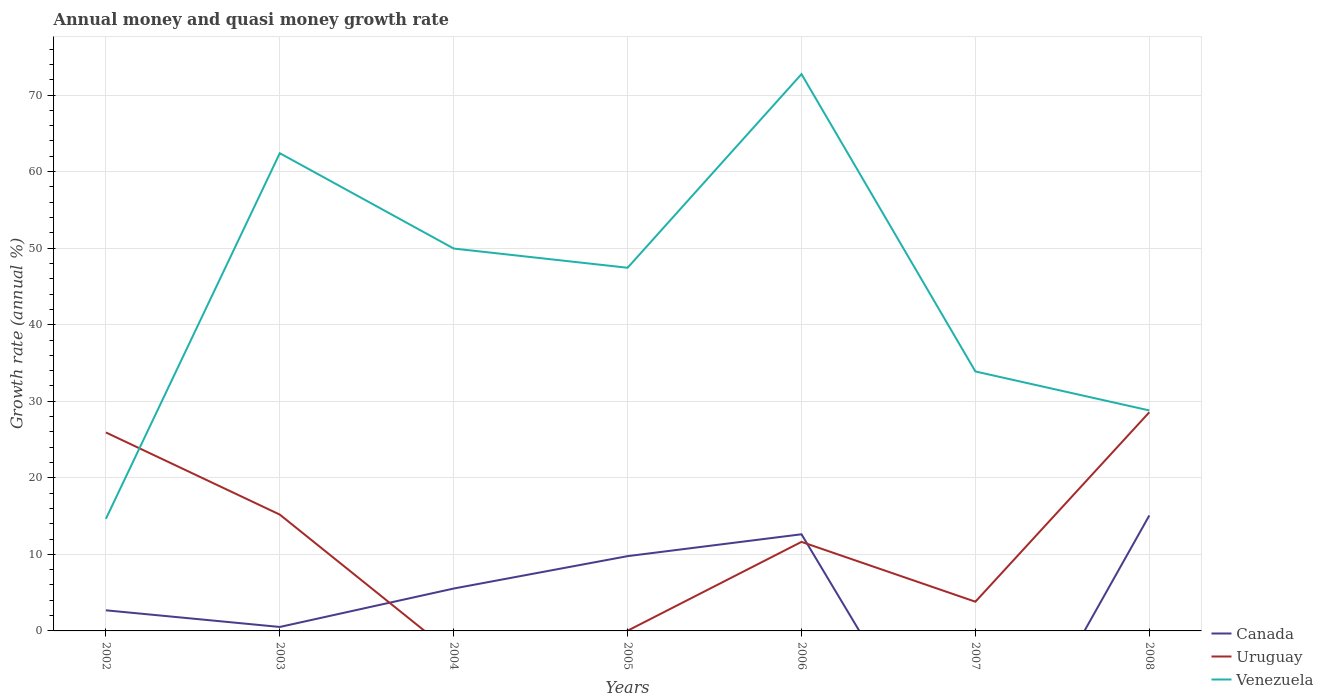Does the line corresponding to Venezuela intersect with the line corresponding to Uruguay?
Offer a very short reply. Yes. Across all years, what is the maximum growth rate in Uruguay?
Give a very brief answer. 0. What is the total growth rate in Uruguay in the graph?
Offer a very short reply. 25.9. What is the difference between the highest and the second highest growth rate in Uruguay?
Provide a succinct answer. 28.57. How many lines are there?
Provide a short and direct response. 3. What is the difference between two consecutive major ticks on the Y-axis?
Ensure brevity in your answer.  10. Does the graph contain any zero values?
Make the answer very short. Yes. Does the graph contain grids?
Ensure brevity in your answer.  Yes. Where does the legend appear in the graph?
Give a very brief answer. Bottom right. How many legend labels are there?
Offer a very short reply. 3. How are the legend labels stacked?
Your answer should be compact. Vertical. What is the title of the graph?
Your response must be concise. Annual money and quasi money growth rate. What is the label or title of the X-axis?
Give a very brief answer. Years. What is the label or title of the Y-axis?
Your answer should be compact. Growth rate (annual %). What is the Growth rate (annual %) in Canada in 2002?
Provide a succinct answer. 2.69. What is the Growth rate (annual %) of Uruguay in 2002?
Keep it short and to the point. 25.93. What is the Growth rate (annual %) in Venezuela in 2002?
Make the answer very short. 14.64. What is the Growth rate (annual %) in Canada in 2003?
Provide a succinct answer. 0.52. What is the Growth rate (annual %) of Uruguay in 2003?
Provide a short and direct response. 15.2. What is the Growth rate (annual %) in Venezuela in 2003?
Provide a succinct answer. 62.41. What is the Growth rate (annual %) in Canada in 2004?
Make the answer very short. 5.54. What is the Growth rate (annual %) in Venezuela in 2004?
Provide a succinct answer. 49.95. What is the Growth rate (annual %) of Canada in 2005?
Offer a terse response. 9.77. What is the Growth rate (annual %) in Uruguay in 2005?
Your answer should be compact. 0.03. What is the Growth rate (annual %) in Venezuela in 2005?
Make the answer very short. 47.44. What is the Growth rate (annual %) in Canada in 2006?
Provide a succinct answer. 12.63. What is the Growth rate (annual %) of Uruguay in 2006?
Keep it short and to the point. 11.63. What is the Growth rate (annual %) in Venezuela in 2006?
Keep it short and to the point. 72.74. What is the Growth rate (annual %) of Uruguay in 2007?
Provide a succinct answer. 3.82. What is the Growth rate (annual %) of Venezuela in 2007?
Your answer should be compact. 33.89. What is the Growth rate (annual %) in Canada in 2008?
Your answer should be very brief. 15.08. What is the Growth rate (annual %) of Uruguay in 2008?
Ensure brevity in your answer.  28.57. What is the Growth rate (annual %) in Venezuela in 2008?
Provide a succinct answer. 28.8. Across all years, what is the maximum Growth rate (annual %) of Canada?
Offer a very short reply. 15.08. Across all years, what is the maximum Growth rate (annual %) in Uruguay?
Your response must be concise. 28.57. Across all years, what is the maximum Growth rate (annual %) of Venezuela?
Your response must be concise. 72.74. Across all years, what is the minimum Growth rate (annual %) in Venezuela?
Provide a short and direct response. 14.64. What is the total Growth rate (annual %) in Canada in the graph?
Ensure brevity in your answer.  46.23. What is the total Growth rate (annual %) in Uruguay in the graph?
Offer a terse response. 85.16. What is the total Growth rate (annual %) in Venezuela in the graph?
Keep it short and to the point. 309.87. What is the difference between the Growth rate (annual %) of Canada in 2002 and that in 2003?
Keep it short and to the point. 2.18. What is the difference between the Growth rate (annual %) of Uruguay in 2002 and that in 2003?
Make the answer very short. 10.73. What is the difference between the Growth rate (annual %) of Venezuela in 2002 and that in 2003?
Ensure brevity in your answer.  -47.77. What is the difference between the Growth rate (annual %) of Canada in 2002 and that in 2004?
Ensure brevity in your answer.  -2.84. What is the difference between the Growth rate (annual %) in Venezuela in 2002 and that in 2004?
Your answer should be very brief. -35.31. What is the difference between the Growth rate (annual %) of Canada in 2002 and that in 2005?
Your response must be concise. -7.08. What is the difference between the Growth rate (annual %) in Uruguay in 2002 and that in 2005?
Keep it short and to the point. 25.9. What is the difference between the Growth rate (annual %) in Venezuela in 2002 and that in 2005?
Give a very brief answer. -32.8. What is the difference between the Growth rate (annual %) in Canada in 2002 and that in 2006?
Your response must be concise. -9.93. What is the difference between the Growth rate (annual %) in Uruguay in 2002 and that in 2006?
Give a very brief answer. 14.3. What is the difference between the Growth rate (annual %) in Venezuela in 2002 and that in 2006?
Your answer should be compact. -58.1. What is the difference between the Growth rate (annual %) of Uruguay in 2002 and that in 2007?
Ensure brevity in your answer.  22.11. What is the difference between the Growth rate (annual %) in Venezuela in 2002 and that in 2007?
Ensure brevity in your answer.  -19.25. What is the difference between the Growth rate (annual %) of Canada in 2002 and that in 2008?
Ensure brevity in your answer.  -12.39. What is the difference between the Growth rate (annual %) in Uruguay in 2002 and that in 2008?
Ensure brevity in your answer.  -2.64. What is the difference between the Growth rate (annual %) of Venezuela in 2002 and that in 2008?
Make the answer very short. -14.16. What is the difference between the Growth rate (annual %) in Canada in 2003 and that in 2004?
Offer a very short reply. -5.02. What is the difference between the Growth rate (annual %) in Venezuela in 2003 and that in 2004?
Your response must be concise. 12.45. What is the difference between the Growth rate (annual %) of Canada in 2003 and that in 2005?
Ensure brevity in your answer.  -9.25. What is the difference between the Growth rate (annual %) in Uruguay in 2003 and that in 2005?
Offer a terse response. 15.17. What is the difference between the Growth rate (annual %) of Venezuela in 2003 and that in 2005?
Ensure brevity in your answer.  14.97. What is the difference between the Growth rate (annual %) of Canada in 2003 and that in 2006?
Your answer should be very brief. -12.11. What is the difference between the Growth rate (annual %) of Uruguay in 2003 and that in 2006?
Offer a terse response. 3.56. What is the difference between the Growth rate (annual %) in Venezuela in 2003 and that in 2006?
Provide a short and direct response. -10.33. What is the difference between the Growth rate (annual %) in Uruguay in 2003 and that in 2007?
Provide a succinct answer. 11.38. What is the difference between the Growth rate (annual %) in Venezuela in 2003 and that in 2007?
Provide a succinct answer. 28.51. What is the difference between the Growth rate (annual %) of Canada in 2003 and that in 2008?
Offer a terse response. -14.57. What is the difference between the Growth rate (annual %) in Uruguay in 2003 and that in 2008?
Provide a succinct answer. -13.37. What is the difference between the Growth rate (annual %) of Venezuela in 2003 and that in 2008?
Keep it short and to the point. 33.6. What is the difference between the Growth rate (annual %) in Canada in 2004 and that in 2005?
Keep it short and to the point. -4.23. What is the difference between the Growth rate (annual %) of Venezuela in 2004 and that in 2005?
Offer a terse response. 2.51. What is the difference between the Growth rate (annual %) of Canada in 2004 and that in 2006?
Offer a terse response. -7.09. What is the difference between the Growth rate (annual %) of Venezuela in 2004 and that in 2006?
Offer a very short reply. -22.78. What is the difference between the Growth rate (annual %) of Venezuela in 2004 and that in 2007?
Your answer should be compact. 16.06. What is the difference between the Growth rate (annual %) in Canada in 2004 and that in 2008?
Provide a succinct answer. -9.55. What is the difference between the Growth rate (annual %) of Venezuela in 2004 and that in 2008?
Offer a very short reply. 21.15. What is the difference between the Growth rate (annual %) of Canada in 2005 and that in 2006?
Provide a succinct answer. -2.86. What is the difference between the Growth rate (annual %) in Uruguay in 2005 and that in 2006?
Give a very brief answer. -11.6. What is the difference between the Growth rate (annual %) in Venezuela in 2005 and that in 2006?
Your response must be concise. -25.3. What is the difference between the Growth rate (annual %) in Uruguay in 2005 and that in 2007?
Offer a terse response. -3.79. What is the difference between the Growth rate (annual %) in Venezuela in 2005 and that in 2007?
Give a very brief answer. 13.55. What is the difference between the Growth rate (annual %) in Canada in 2005 and that in 2008?
Your response must be concise. -5.31. What is the difference between the Growth rate (annual %) of Uruguay in 2005 and that in 2008?
Your answer should be very brief. -28.54. What is the difference between the Growth rate (annual %) of Venezuela in 2005 and that in 2008?
Your answer should be compact. 18.64. What is the difference between the Growth rate (annual %) of Uruguay in 2006 and that in 2007?
Ensure brevity in your answer.  7.82. What is the difference between the Growth rate (annual %) in Venezuela in 2006 and that in 2007?
Make the answer very short. 38.84. What is the difference between the Growth rate (annual %) in Canada in 2006 and that in 2008?
Offer a terse response. -2.46. What is the difference between the Growth rate (annual %) of Uruguay in 2006 and that in 2008?
Provide a succinct answer. -16.93. What is the difference between the Growth rate (annual %) in Venezuela in 2006 and that in 2008?
Offer a terse response. 43.94. What is the difference between the Growth rate (annual %) in Uruguay in 2007 and that in 2008?
Your answer should be compact. -24.75. What is the difference between the Growth rate (annual %) of Venezuela in 2007 and that in 2008?
Give a very brief answer. 5.09. What is the difference between the Growth rate (annual %) of Canada in 2002 and the Growth rate (annual %) of Uruguay in 2003?
Make the answer very short. -12.5. What is the difference between the Growth rate (annual %) of Canada in 2002 and the Growth rate (annual %) of Venezuela in 2003?
Your answer should be compact. -59.71. What is the difference between the Growth rate (annual %) of Uruguay in 2002 and the Growth rate (annual %) of Venezuela in 2003?
Provide a short and direct response. -36.48. What is the difference between the Growth rate (annual %) in Canada in 2002 and the Growth rate (annual %) in Venezuela in 2004?
Make the answer very short. -47.26. What is the difference between the Growth rate (annual %) of Uruguay in 2002 and the Growth rate (annual %) of Venezuela in 2004?
Keep it short and to the point. -24.02. What is the difference between the Growth rate (annual %) of Canada in 2002 and the Growth rate (annual %) of Uruguay in 2005?
Your response must be concise. 2.67. What is the difference between the Growth rate (annual %) in Canada in 2002 and the Growth rate (annual %) in Venezuela in 2005?
Offer a very short reply. -44.75. What is the difference between the Growth rate (annual %) of Uruguay in 2002 and the Growth rate (annual %) of Venezuela in 2005?
Provide a succinct answer. -21.51. What is the difference between the Growth rate (annual %) of Canada in 2002 and the Growth rate (annual %) of Uruguay in 2006?
Make the answer very short. -8.94. What is the difference between the Growth rate (annual %) in Canada in 2002 and the Growth rate (annual %) in Venezuela in 2006?
Offer a very short reply. -70.04. What is the difference between the Growth rate (annual %) in Uruguay in 2002 and the Growth rate (annual %) in Venezuela in 2006?
Give a very brief answer. -46.81. What is the difference between the Growth rate (annual %) in Canada in 2002 and the Growth rate (annual %) in Uruguay in 2007?
Offer a very short reply. -1.12. What is the difference between the Growth rate (annual %) in Canada in 2002 and the Growth rate (annual %) in Venezuela in 2007?
Ensure brevity in your answer.  -31.2. What is the difference between the Growth rate (annual %) of Uruguay in 2002 and the Growth rate (annual %) of Venezuela in 2007?
Your answer should be very brief. -7.97. What is the difference between the Growth rate (annual %) of Canada in 2002 and the Growth rate (annual %) of Uruguay in 2008?
Keep it short and to the point. -25.87. What is the difference between the Growth rate (annual %) of Canada in 2002 and the Growth rate (annual %) of Venezuela in 2008?
Offer a terse response. -26.11. What is the difference between the Growth rate (annual %) in Uruguay in 2002 and the Growth rate (annual %) in Venezuela in 2008?
Offer a very short reply. -2.87. What is the difference between the Growth rate (annual %) in Canada in 2003 and the Growth rate (annual %) in Venezuela in 2004?
Provide a short and direct response. -49.43. What is the difference between the Growth rate (annual %) of Uruguay in 2003 and the Growth rate (annual %) of Venezuela in 2004?
Your answer should be compact. -34.76. What is the difference between the Growth rate (annual %) of Canada in 2003 and the Growth rate (annual %) of Uruguay in 2005?
Keep it short and to the point. 0.49. What is the difference between the Growth rate (annual %) of Canada in 2003 and the Growth rate (annual %) of Venezuela in 2005?
Provide a short and direct response. -46.92. What is the difference between the Growth rate (annual %) in Uruguay in 2003 and the Growth rate (annual %) in Venezuela in 2005?
Your response must be concise. -32.24. What is the difference between the Growth rate (annual %) in Canada in 2003 and the Growth rate (annual %) in Uruguay in 2006?
Provide a short and direct response. -11.11. What is the difference between the Growth rate (annual %) of Canada in 2003 and the Growth rate (annual %) of Venezuela in 2006?
Provide a succinct answer. -72.22. What is the difference between the Growth rate (annual %) of Uruguay in 2003 and the Growth rate (annual %) of Venezuela in 2006?
Ensure brevity in your answer.  -57.54. What is the difference between the Growth rate (annual %) of Canada in 2003 and the Growth rate (annual %) of Uruguay in 2007?
Provide a short and direct response. -3.3. What is the difference between the Growth rate (annual %) in Canada in 2003 and the Growth rate (annual %) in Venezuela in 2007?
Offer a very short reply. -33.38. What is the difference between the Growth rate (annual %) in Uruguay in 2003 and the Growth rate (annual %) in Venezuela in 2007?
Your answer should be very brief. -18.7. What is the difference between the Growth rate (annual %) in Canada in 2003 and the Growth rate (annual %) in Uruguay in 2008?
Provide a succinct answer. -28.05. What is the difference between the Growth rate (annual %) in Canada in 2003 and the Growth rate (annual %) in Venezuela in 2008?
Your response must be concise. -28.28. What is the difference between the Growth rate (annual %) in Uruguay in 2003 and the Growth rate (annual %) in Venezuela in 2008?
Provide a short and direct response. -13.6. What is the difference between the Growth rate (annual %) of Canada in 2004 and the Growth rate (annual %) of Uruguay in 2005?
Keep it short and to the point. 5.51. What is the difference between the Growth rate (annual %) of Canada in 2004 and the Growth rate (annual %) of Venezuela in 2005?
Your answer should be compact. -41.9. What is the difference between the Growth rate (annual %) of Canada in 2004 and the Growth rate (annual %) of Uruguay in 2006?
Provide a succinct answer. -6.09. What is the difference between the Growth rate (annual %) of Canada in 2004 and the Growth rate (annual %) of Venezuela in 2006?
Your answer should be compact. -67.2. What is the difference between the Growth rate (annual %) of Canada in 2004 and the Growth rate (annual %) of Uruguay in 2007?
Offer a very short reply. 1.72. What is the difference between the Growth rate (annual %) in Canada in 2004 and the Growth rate (annual %) in Venezuela in 2007?
Keep it short and to the point. -28.36. What is the difference between the Growth rate (annual %) in Canada in 2004 and the Growth rate (annual %) in Uruguay in 2008?
Your response must be concise. -23.03. What is the difference between the Growth rate (annual %) in Canada in 2004 and the Growth rate (annual %) in Venezuela in 2008?
Ensure brevity in your answer.  -23.26. What is the difference between the Growth rate (annual %) of Canada in 2005 and the Growth rate (annual %) of Uruguay in 2006?
Ensure brevity in your answer.  -1.86. What is the difference between the Growth rate (annual %) in Canada in 2005 and the Growth rate (annual %) in Venezuela in 2006?
Offer a very short reply. -62.97. What is the difference between the Growth rate (annual %) in Uruguay in 2005 and the Growth rate (annual %) in Venezuela in 2006?
Give a very brief answer. -72.71. What is the difference between the Growth rate (annual %) in Canada in 2005 and the Growth rate (annual %) in Uruguay in 2007?
Keep it short and to the point. 5.95. What is the difference between the Growth rate (annual %) of Canada in 2005 and the Growth rate (annual %) of Venezuela in 2007?
Offer a terse response. -24.12. What is the difference between the Growth rate (annual %) of Uruguay in 2005 and the Growth rate (annual %) of Venezuela in 2007?
Ensure brevity in your answer.  -33.87. What is the difference between the Growth rate (annual %) of Canada in 2005 and the Growth rate (annual %) of Uruguay in 2008?
Ensure brevity in your answer.  -18.8. What is the difference between the Growth rate (annual %) of Canada in 2005 and the Growth rate (annual %) of Venezuela in 2008?
Your response must be concise. -19.03. What is the difference between the Growth rate (annual %) in Uruguay in 2005 and the Growth rate (annual %) in Venezuela in 2008?
Your answer should be very brief. -28.77. What is the difference between the Growth rate (annual %) of Canada in 2006 and the Growth rate (annual %) of Uruguay in 2007?
Make the answer very short. 8.81. What is the difference between the Growth rate (annual %) of Canada in 2006 and the Growth rate (annual %) of Venezuela in 2007?
Your response must be concise. -21.27. What is the difference between the Growth rate (annual %) in Uruguay in 2006 and the Growth rate (annual %) in Venezuela in 2007?
Your response must be concise. -22.26. What is the difference between the Growth rate (annual %) in Canada in 2006 and the Growth rate (annual %) in Uruguay in 2008?
Your answer should be compact. -15.94. What is the difference between the Growth rate (annual %) in Canada in 2006 and the Growth rate (annual %) in Venezuela in 2008?
Your answer should be compact. -16.18. What is the difference between the Growth rate (annual %) of Uruguay in 2006 and the Growth rate (annual %) of Venezuela in 2008?
Make the answer very short. -17.17. What is the difference between the Growth rate (annual %) in Uruguay in 2007 and the Growth rate (annual %) in Venezuela in 2008?
Make the answer very short. -24.99. What is the average Growth rate (annual %) in Canada per year?
Offer a very short reply. 6.6. What is the average Growth rate (annual %) in Uruguay per year?
Provide a succinct answer. 12.17. What is the average Growth rate (annual %) in Venezuela per year?
Keep it short and to the point. 44.27. In the year 2002, what is the difference between the Growth rate (annual %) of Canada and Growth rate (annual %) of Uruguay?
Offer a very short reply. -23.23. In the year 2002, what is the difference between the Growth rate (annual %) of Canada and Growth rate (annual %) of Venezuela?
Your response must be concise. -11.95. In the year 2002, what is the difference between the Growth rate (annual %) in Uruguay and Growth rate (annual %) in Venezuela?
Give a very brief answer. 11.29. In the year 2003, what is the difference between the Growth rate (annual %) of Canada and Growth rate (annual %) of Uruguay?
Your response must be concise. -14.68. In the year 2003, what is the difference between the Growth rate (annual %) of Canada and Growth rate (annual %) of Venezuela?
Your answer should be very brief. -61.89. In the year 2003, what is the difference between the Growth rate (annual %) of Uruguay and Growth rate (annual %) of Venezuela?
Make the answer very short. -47.21. In the year 2004, what is the difference between the Growth rate (annual %) of Canada and Growth rate (annual %) of Venezuela?
Your answer should be compact. -44.41. In the year 2005, what is the difference between the Growth rate (annual %) in Canada and Growth rate (annual %) in Uruguay?
Your response must be concise. 9.74. In the year 2005, what is the difference between the Growth rate (annual %) in Canada and Growth rate (annual %) in Venezuela?
Your answer should be compact. -37.67. In the year 2005, what is the difference between the Growth rate (annual %) in Uruguay and Growth rate (annual %) in Venezuela?
Keep it short and to the point. -47.41. In the year 2006, what is the difference between the Growth rate (annual %) of Canada and Growth rate (annual %) of Venezuela?
Keep it short and to the point. -60.11. In the year 2006, what is the difference between the Growth rate (annual %) in Uruguay and Growth rate (annual %) in Venezuela?
Make the answer very short. -61.1. In the year 2007, what is the difference between the Growth rate (annual %) in Uruguay and Growth rate (annual %) in Venezuela?
Offer a terse response. -30.08. In the year 2008, what is the difference between the Growth rate (annual %) in Canada and Growth rate (annual %) in Uruguay?
Keep it short and to the point. -13.48. In the year 2008, what is the difference between the Growth rate (annual %) in Canada and Growth rate (annual %) in Venezuela?
Provide a succinct answer. -13.72. In the year 2008, what is the difference between the Growth rate (annual %) of Uruguay and Growth rate (annual %) of Venezuela?
Offer a terse response. -0.24. What is the ratio of the Growth rate (annual %) in Canada in 2002 to that in 2003?
Your response must be concise. 5.2. What is the ratio of the Growth rate (annual %) of Uruguay in 2002 to that in 2003?
Provide a succinct answer. 1.71. What is the ratio of the Growth rate (annual %) in Venezuela in 2002 to that in 2003?
Your answer should be compact. 0.23. What is the ratio of the Growth rate (annual %) in Canada in 2002 to that in 2004?
Keep it short and to the point. 0.49. What is the ratio of the Growth rate (annual %) in Venezuela in 2002 to that in 2004?
Provide a succinct answer. 0.29. What is the ratio of the Growth rate (annual %) of Canada in 2002 to that in 2005?
Make the answer very short. 0.28. What is the ratio of the Growth rate (annual %) of Uruguay in 2002 to that in 2005?
Make the answer very short. 943.27. What is the ratio of the Growth rate (annual %) of Venezuela in 2002 to that in 2005?
Provide a short and direct response. 0.31. What is the ratio of the Growth rate (annual %) in Canada in 2002 to that in 2006?
Give a very brief answer. 0.21. What is the ratio of the Growth rate (annual %) of Uruguay in 2002 to that in 2006?
Offer a terse response. 2.23. What is the ratio of the Growth rate (annual %) in Venezuela in 2002 to that in 2006?
Offer a very short reply. 0.2. What is the ratio of the Growth rate (annual %) in Uruguay in 2002 to that in 2007?
Ensure brevity in your answer.  6.8. What is the ratio of the Growth rate (annual %) of Venezuela in 2002 to that in 2007?
Ensure brevity in your answer.  0.43. What is the ratio of the Growth rate (annual %) of Canada in 2002 to that in 2008?
Offer a very short reply. 0.18. What is the ratio of the Growth rate (annual %) of Uruguay in 2002 to that in 2008?
Offer a very short reply. 0.91. What is the ratio of the Growth rate (annual %) of Venezuela in 2002 to that in 2008?
Ensure brevity in your answer.  0.51. What is the ratio of the Growth rate (annual %) in Canada in 2003 to that in 2004?
Your response must be concise. 0.09. What is the ratio of the Growth rate (annual %) in Venezuela in 2003 to that in 2004?
Offer a very short reply. 1.25. What is the ratio of the Growth rate (annual %) of Canada in 2003 to that in 2005?
Provide a succinct answer. 0.05. What is the ratio of the Growth rate (annual %) in Uruguay in 2003 to that in 2005?
Make the answer very short. 552.86. What is the ratio of the Growth rate (annual %) of Venezuela in 2003 to that in 2005?
Give a very brief answer. 1.32. What is the ratio of the Growth rate (annual %) of Canada in 2003 to that in 2006?
Keep it short and to the point. 0.04. What is the ratio of the Growth rate (annual %) of Uruguay in 2003 to that in 2006?
Offer a terse response. 1.31. What is the ratio of the Growth rate (annual %) of Venezuela in 2003 to that in 2006?
Keep it short and to the point. 0.86. What is the ratio of the Growth rate (annual %) of Uruguay in 2003 to that in 2007?
Provide a short and direct response. 3.98. What is the ratio of the Growth rate (annual %) of Venezuela in 2003 to that in 2007?
Offer a terse response. 1.84. What is the ratio of the Growth rate (annual %) of Canada in 2003 to that in 2008?
Provide a short and direct response. 0.03. What is the ratio of the Growth rate (annual %) of Uruguay in 2003 to that in 2008?
Your answer should be very brief. 0.53. What is the ratio of the Growth rate (annual %) in Venezuela in 2003 to that in 2008?
Offer a very short reply. 2.17. What is the ratio of the Growth rate (annual %) of Canada in 2004 to that in 2005?
Offer a terse response. 0.57. What is the ratio of the Growth rate (annual %) in Venezuela in 2004 to that in 2005?
Keep it short and to the point. 1.05. What is the ratio of the Growth rate (annual %) of Canada in 2004 to that in 2006?
Your answer should be very brief. 0.44. What is the ratio of the Growth rate (annual %) of Venezuela in 2004 to that in 2006?
Keep it short and to the point. 0.69. What is the ratio of the Growth rate (annual %) of Venezuela in 2004 to that in 2007?
Give a very brief answer. 1.47. What is the ratio of the Growth rate (annual %) of Canada in 2004 to that in 2008?
Provide a succinct answer. 0.37. What is the ratio of the Growth rate (annual %) of Venezuela in 2004 to that in 2008?
Ensure brevity in your answer.  1.73. What is the ratio of the Growth rate (annual %) in Canada in 2005 to that in 2006?
Offer a very short reply. 0.77. What is the ratio of the Growth rate (annual %) in Uruguay in 2005 to that in 2006?
Offer a very short reply. 0. What is the ratio of the Growth rate (annual %) in Venezuela in 2005 to that in 2006?
Make the answer very short. 0.65. What is the ratio of the Growth rate (annual %) in Uruguay in 2005 to that in 2007?
Provide a short and direct response. 0.01. What is the ratio of the Growth rate (annual %) in Venezuela in 2005 to that in 2007?
Your answer should be very brief. 1.4. What is the ratio of the Growth rate (annual %) in Canada in 2005 to that in 2008?
Ensure brevity in your answer.  0.65. What is the ratio of the Growth rate (annual %) in Uruguay in 2005 to that in 2008?
Keep it short and to the point. 0. What is the ratio of the Growth rate (annual %) of Venezuela in 2005 to that in 2008?
Provide a short and direct response. 1.65. What is the ratio of the Growth rate (annual %) in Uruguay in 2006 to that in 2007?
Provide a short and direct response. 3.05. What is the ratio of the Growth rate (annual %) in Venezuela in 2006 to that in 2007?
Your response must be concise. 2.15. What is the ratio of the Growth rate (annual %) in Canada in 2006 to that in 2008?
Provide a succinct answer. 0.84. What is the ratio of the Growth rate (annual %) of Uruguay in 2006 to that in 2008?
Offer a terse response. 0.41. What is the ratio of the Growth rate (annual %) in Venezuela in 2006 to that in 2008?
Your answer should be very brief. 2.53. What is the ratio of the Growth rate (annual %) of Uruguay in 2007 to that in 2008?
Ensure brevity in your answer.  0.13. What is the ratio of the Growth rate (annual %) in Venezuela in 2007 to that in 2008?
Make the answer very short. 1.18. What is the difference between the highest and the second highest Growth rate (annual %) in Canada?
Offer a very short reply. 2.46. What is the difference between the highest and the second highest Growth rate (annual %) of Uruguay?
Make the answer very short. 2.64. What is the difference between the highest and the second highest Growth rate (annual %) of Venezuela?
Provide a short and direct response. 10.33. What is the difference between the highest and the lowest Growth rate (annual %) in Canada?
Offer a terse response. 15.08. What is the difference between the highest and the lowest Growth rate (annual %) of Uruguay?
Make the answer very short. 28.57. What is the difference between the highest and the lowest Growth rate (annual %) in Venezuela?
Ensure brevity in your answer.  58.1. 